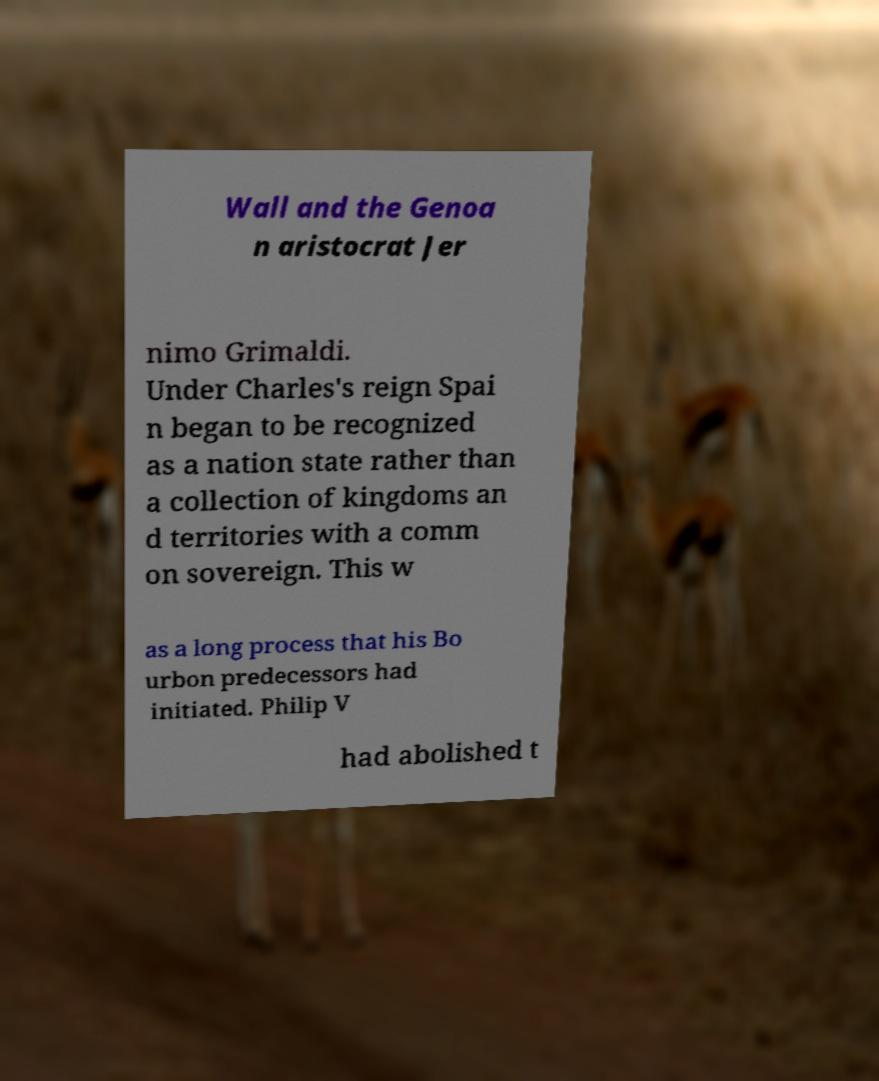For documentation purposes, I need the text within this image transcribed. Could you provide that? Wall and the Genoa n aristocrat Jer nimo Grimaldi. Under Charles's reign Spai n began to be recognized as a nation state rather than a collection of kingdoms an d territories with a comm on sovereign. This w as a long process that his Bo urbon predecessors had initiated. Philip V had abolished t 